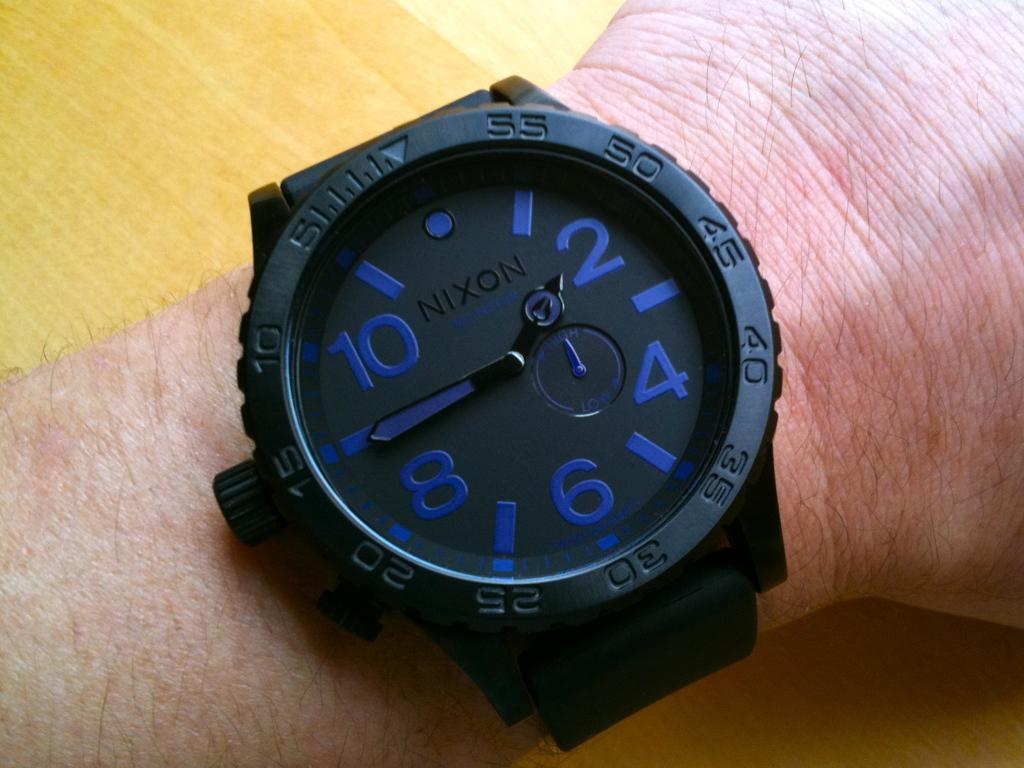What part of a person is visible in the image? There is a person's hand in the image. What is the person wearing on their wrist? The person is wearing a wristwatch. What color is the wristwatch? The wristwatch is black. How does the wristwatch display the time? The wristwatch is an analog watch. What advice does the bird give to the person in the image? There is no bird present in the image, so it cannot give any advice. 